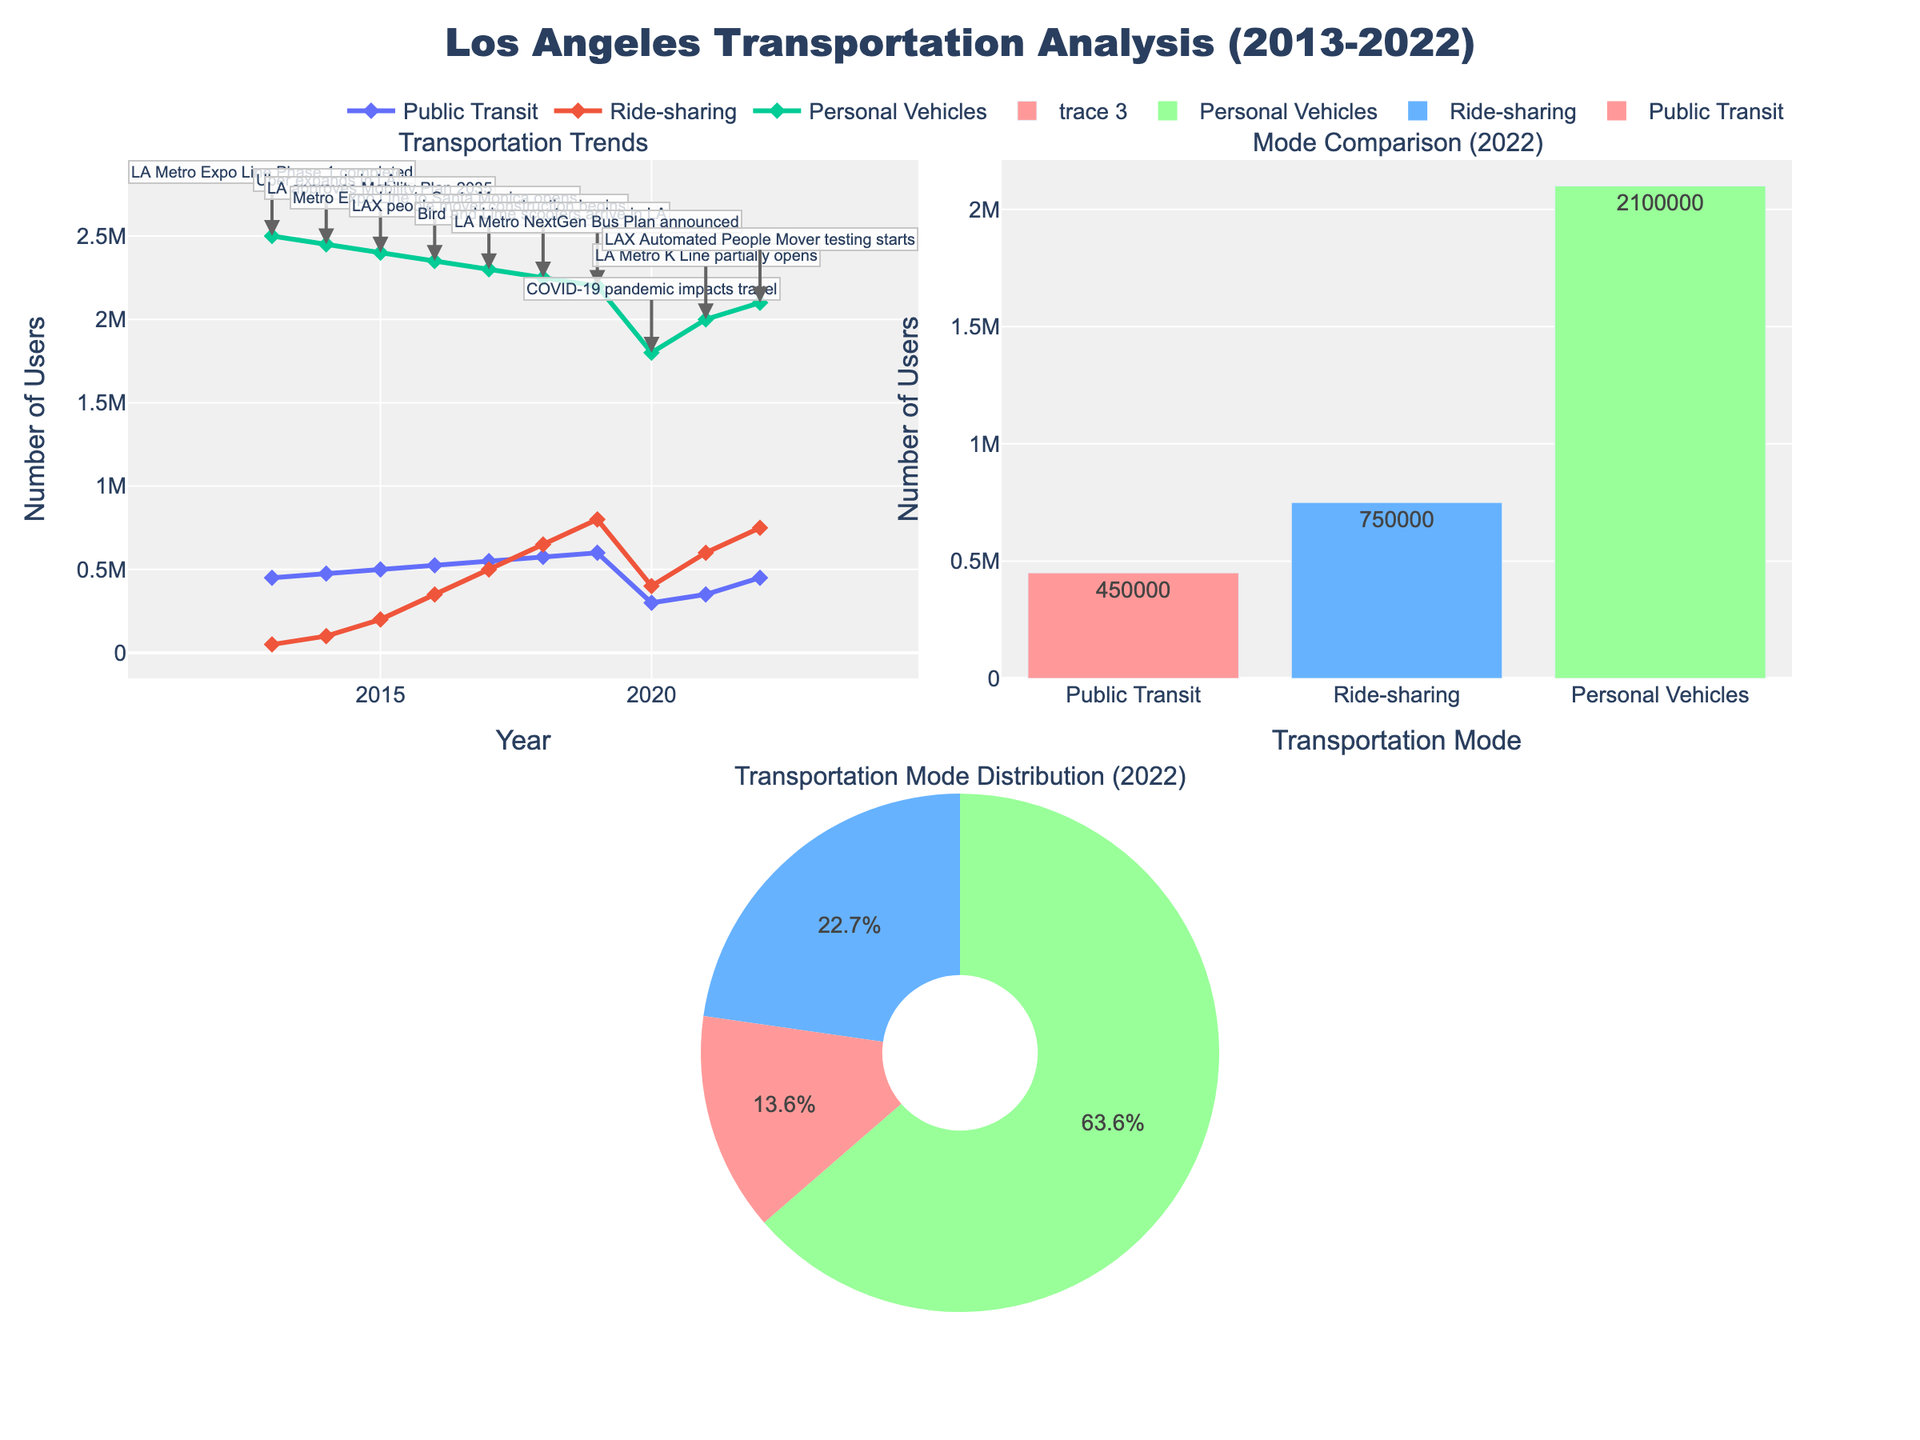What is the title of the plot? The title of the plot is displayed at the top and reads "Los Angeles Transportation Analysis (2013-2022)."
Answer: Los Angeles Transportation Analysis (2013-2022) Which transportation mode had the highest number of users in 2022? Referring to the bar chart in the top right, the "Personal Vehicles" category has the highest bar, indicating it had the most users in 2022.
Answer: Personal Vehicles How many users used Public Transit in 2020? In the line plot for transportation trends on the top left, the point corresponding to Public Transit in 2020 shows 300,000 users.
Answer: 300,000 What is the difference in the number of ride-sharing users between 2014 and 2020? In the line plot in the top left, the number of ride-sharing users for 2014 is 100,000 and for 2020 is 400,000. The difference is calculated as 400,000 - 100,000.
Answer: 300,000 Which year displayed a significant drop in public transit users, and what was the event? The line plot shows a noticeable drop in public transit users in 2020. The annotation for 2020 indicates that the "COVID-19 pandemic impacts travel" was the major event that year.
Answer: 2020, COVID-19 pandemic How do the numbers of ride-sharing users and public transit users compare in 2018? In the line plot, the number of ride-sharing users in 2018 is 650,000, and the number of public transit users is 575,000. Ride-sharing users were more than public transit users.
Answer: Ride-sharing > Public Transit What are the proportions of different transport modes in 2022? The pie chart in the bottom left shows the proportions for 2022. We can see that Personal Vehicles have the largest slice, followed by Ride-sharing, and then Public Transit.
Answer: Personal Vehicles: highest, Ride-sharing: medium, Public Transit: lowest What was the major event in 2016, and how did it impact public transit users? The annotation for 2016 indicates the major event as the "Metro Expo Line to Santa Monica opens." The corresponding line shows an increase in public transit users to 525,000.
Answer: Metro Expo Line to Santa Monica opens, Increase in users Which transportation mode grew the most from 2013 to 2022? By comparing the start and end points in the line plot, Ride-sharing shows the most significant increase. It grew from 50,000 in 2013 to 750,000 in 2022.
Answer: Ride-sharing 